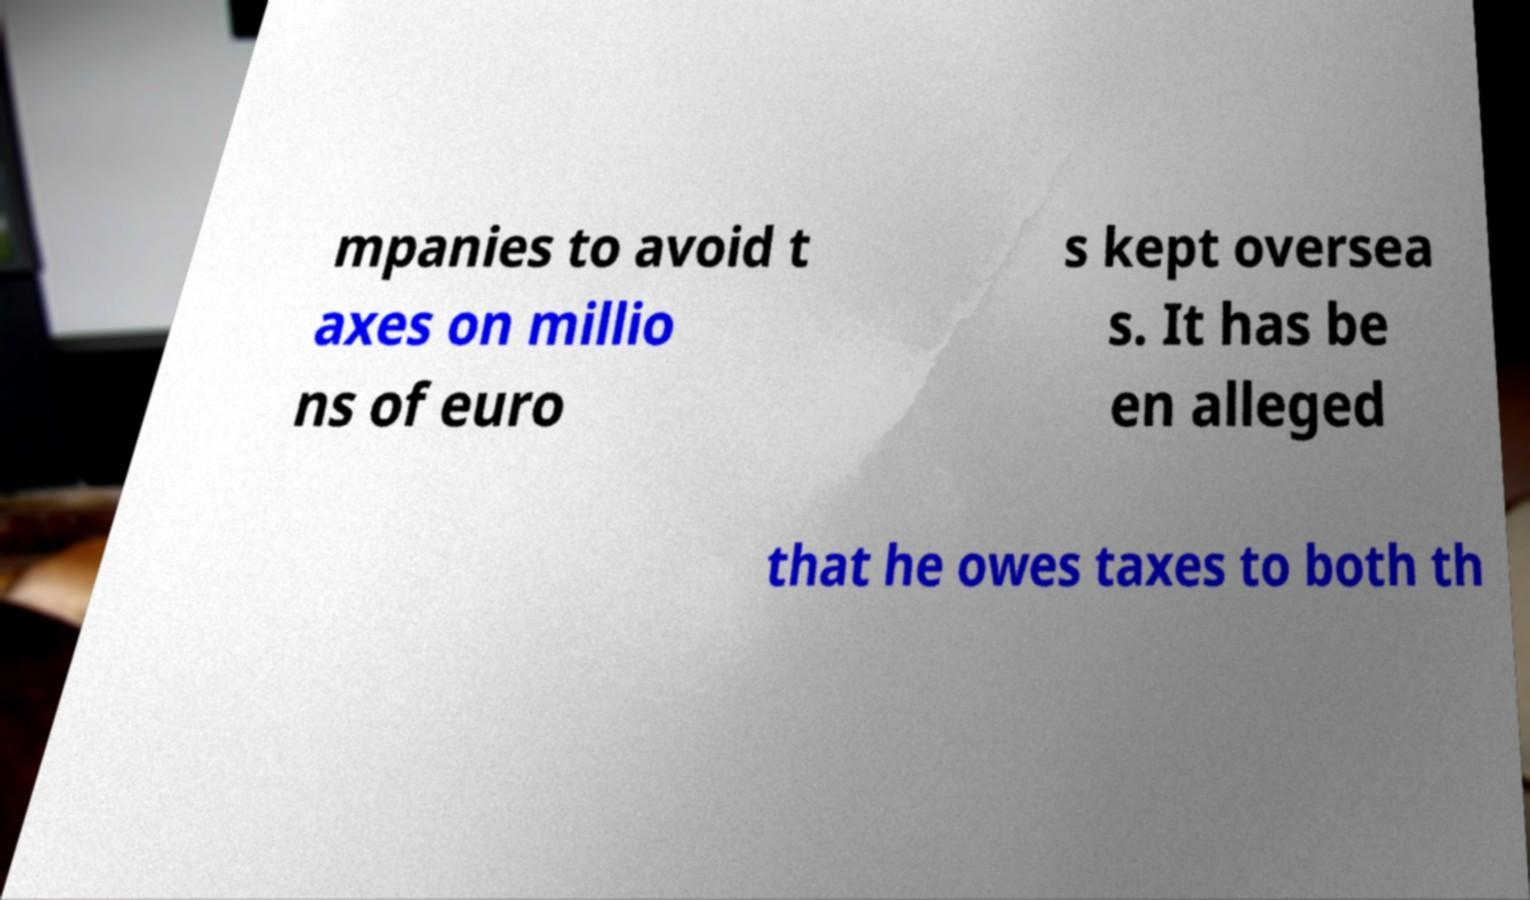Please read and relay the text visible in this image. What does it say? mpanies to avoid t axes on millio ns of euro s kept oversea s. It has be en alleged that he owes taxes to both th 